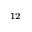Convert formula to latex. <formula><loc_0><loc_0><loc_500><loc_500>^ { 1 2 }</formula> 